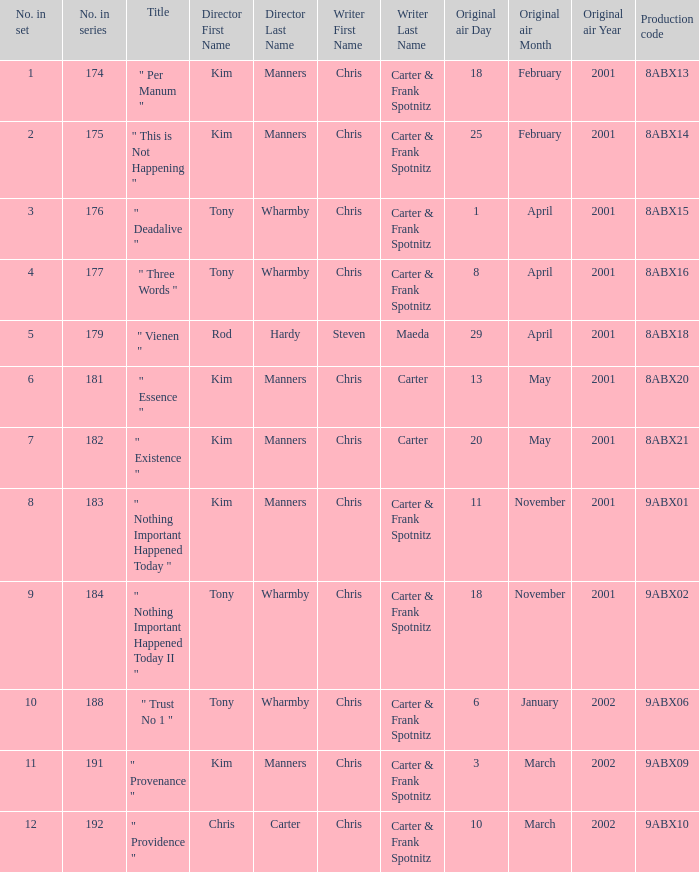What is the episode number that has production code 8abx15? 176.0. 